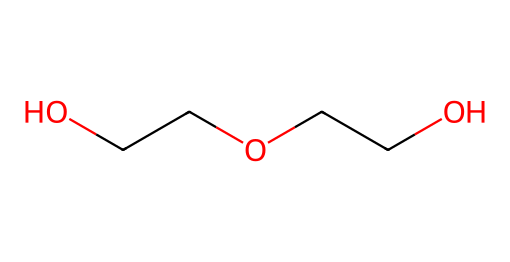What is the name of this chemical? The SMILES representation indicates a chemical made up of ethylene glycol units. In common terms, it is referred to as polyethylene glycol (PEG).
Answer: polyethylene glycol How many carbon atoms are in this structure? By examining the SMILES "OCCOCCO," we can identify that each "C" represents a carbon atom. There are four carbon atoms present in total.
Answer: four What is the primary functional group present in this chemical? The structure includes hydroxyl (-OH) groups that arise from the -O- connections to carbon atoms. This indicates it's an alcohol, specifically a polyol.
Answer: alcohol How many oxygen atoms does this chemical contain? The SMILES shows three "O" characters, which correspond to three oxygen atoms in the chemical structure.
Answer: three Is this chemical soluble in water? Polyethylene glycol is known for its high solubility in water due to its polar –OH groups that facilitate interaction with water molecules.
Answer: yes What type of compound is this chemical primarily used as in automotive brake fluid? Polyethylene glycol is utilized in brake fluid due to its hygroscopic properties and ability to maintain performance under varying temperatures, classifying it as a functional fluid.
Answer: functional fluid What property of this molecule contributes most to its high boiling point? The presence of extensive hydrogen bonding due to the hydroxyl groups in polyethylene glycol is what gives it a significantly higher boiling point compared to hydrocarbons.
Answer: hydrogen bonding 